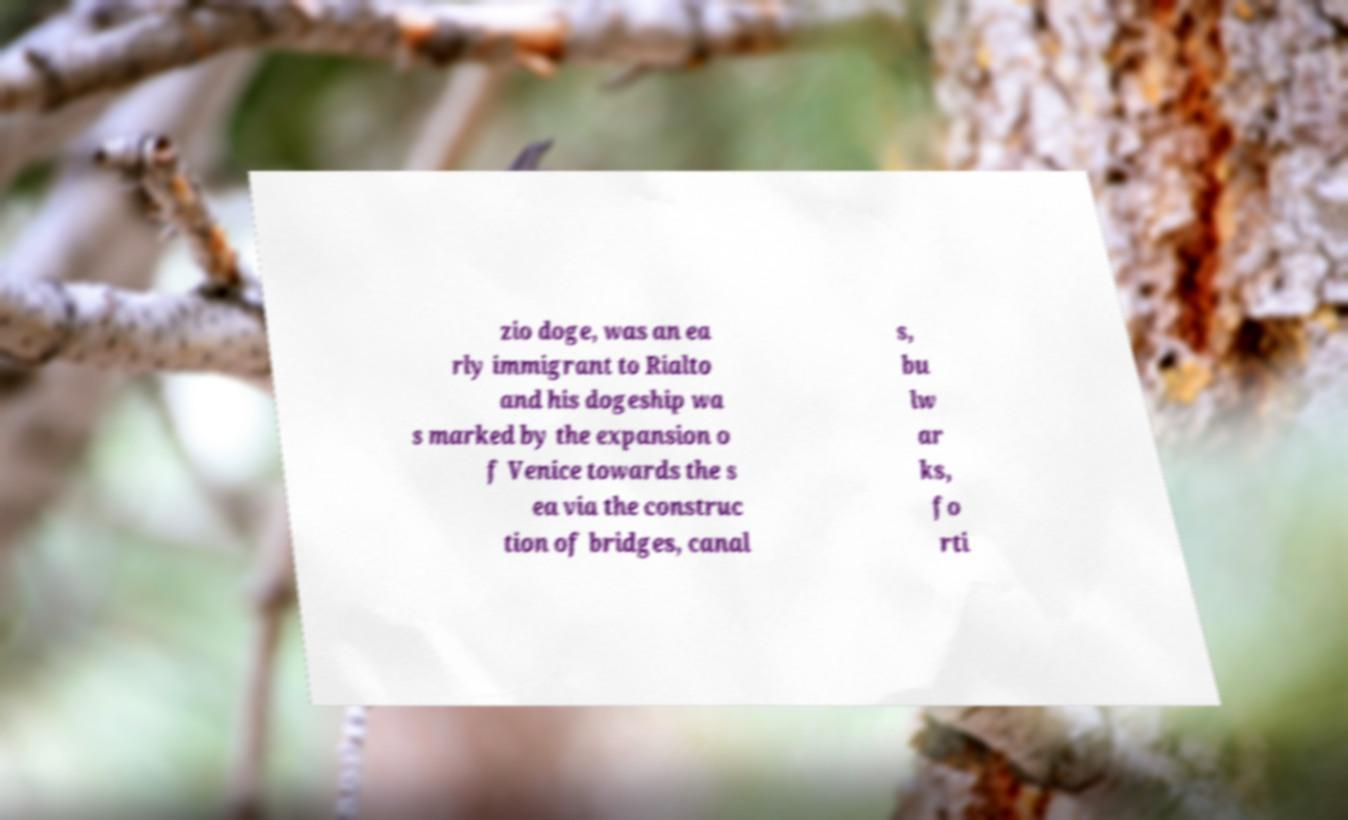Can you accurately transcribe the text from the provided image for me? zio doge, was an ea rly immigrant to Rialto and his dogeship wa s marked by the expansion o f Venice towards the s ea via the construc tion of bridges, canal s, bu lw ar ks, fo rti 